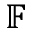<formula> <loc_0><loc_0><loc_500><loc_500>\mathbb { F }</formula> 